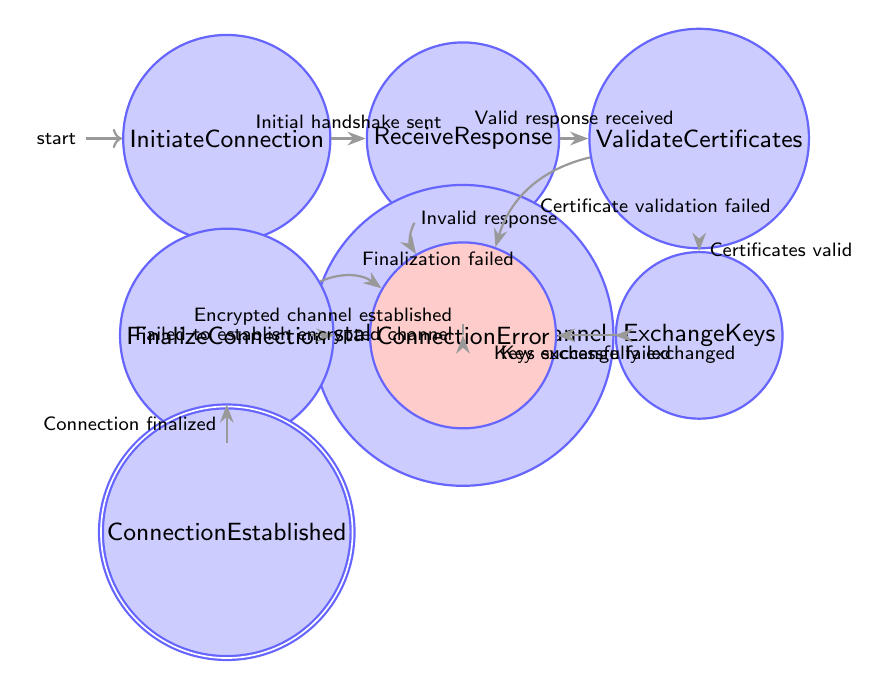What is the first state in the diagram? The diagram starts with the state labeled "InitiateConnection," which represents the initial action of starting the connection process.
Answer: InitiateConnection How many total states are in the diagram? By counting the states listed within the diagram, we have the following states: InitiateConnection, ReceiveResponse, ValidateCertificates, ExchangeKeys, EstablishEncryptedChannel, FinalizeConnection, ConnectionEstablished, and ConnectionError, totaling 8 states.
Answer: 8 What is the condition for transitioning from "ExchangeKeys" to "EstablishEncryptedChannel"? The transition from the state "ExchangeKeys" to "EstablishEncryptedChannel" occurs when the condition "Keys successfully exchanged" is met, indicating that the key exchange process has been completed successfully.
Answer: Keys successfully exchanged What happens if an "Invalid response" is received in the "ReceiveResponse" state? If an "Invalid response" is received, the diagram indicates that the flow transitions to the "ConnectionError" state, which signifies that an error occurred during the connection setup process.
Answer: ConnectionError What is the last state before "ConnectionEstablished"? The last state before reaching "ConnectionEstablished" is "FinalizeConnection," where the connection is confirmed and finalized before establishing secure communication.
Answer: FinalizeConnection Which state leads to connection termination if there is a "Key exchange failed"? The state "ExchangeKeys" leads to "ConnectionError" if there is a "Key exchange failed," indicating a critical issue in the key exchange phase of the connection setup.
Answer: ConnectionError What condition must be met to transition from "FinalizeConnection" to "ConnectionEstablished"? The transition from "FinalizeConnection" to "ConnectionEstablished" requires the condition "Connection finalized" to be satisfied, confirming that all steps have completed successfully to establish the secure connection.
Answer: Connection finalized How many transitions lead to "ConnectionError"? There are five transitions that lead to the "ConnectionError" state in the diagram. These occur due to invalid responses or failures at various stages of the connection setup process.
Answer: 5 